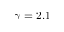<formula> <loc_0><loc_0><loc_500><loc_500>\gamma = 2 . 1</formula> 